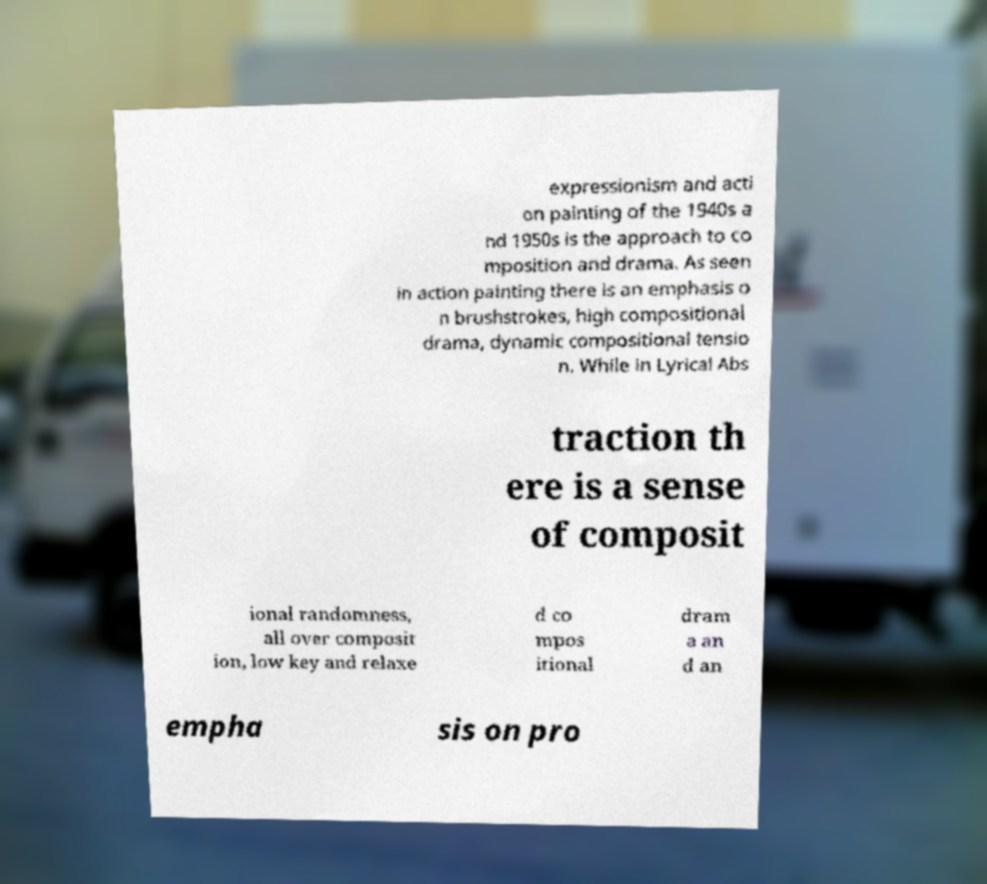There's text embedded in this image that I need extracted. Can you transcribe it verbatim? expressionism and acti on painting of the 1940s a nd 1950s is the approach to co mposition and drama. As seen in action painting there is an emphasis o n brushstrokes, high compositional drama, dynamic compositional tensio n. While in Lyrical Abs traction th ere is a sense of composit ional randomness, all over composit ion, low key and relaxe d co mpos itional dram a an d an empha sis on pro 